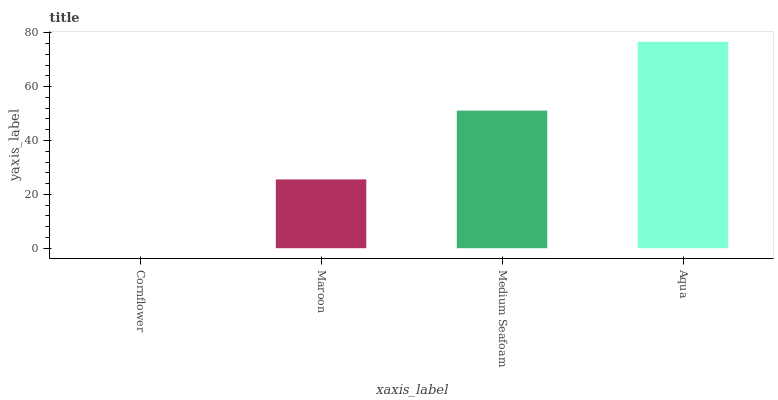Is Maroon the minimum?
Answer yes or no. No. Is Maroon the maximum?
Answer yes or no. No. Is Maroon greater than Cornflower?
Answer yes or no. Yes. Is Cornflower less than Maroon?
Answer yes or no. Yes. Is Cornflower greater than Maroon?
Answer yes or no. No. Is Maroon less than Cornflower?
Answer yes or no. No. Is Medium Seafoam the high median?
Answer yes or no. Yes. Is Maroon the low median?
Answer yes or no. Yes. Is Aqua the high median?
Answer yes or no. No. Is Cornflower the low median?
Answer yes or no. No. 